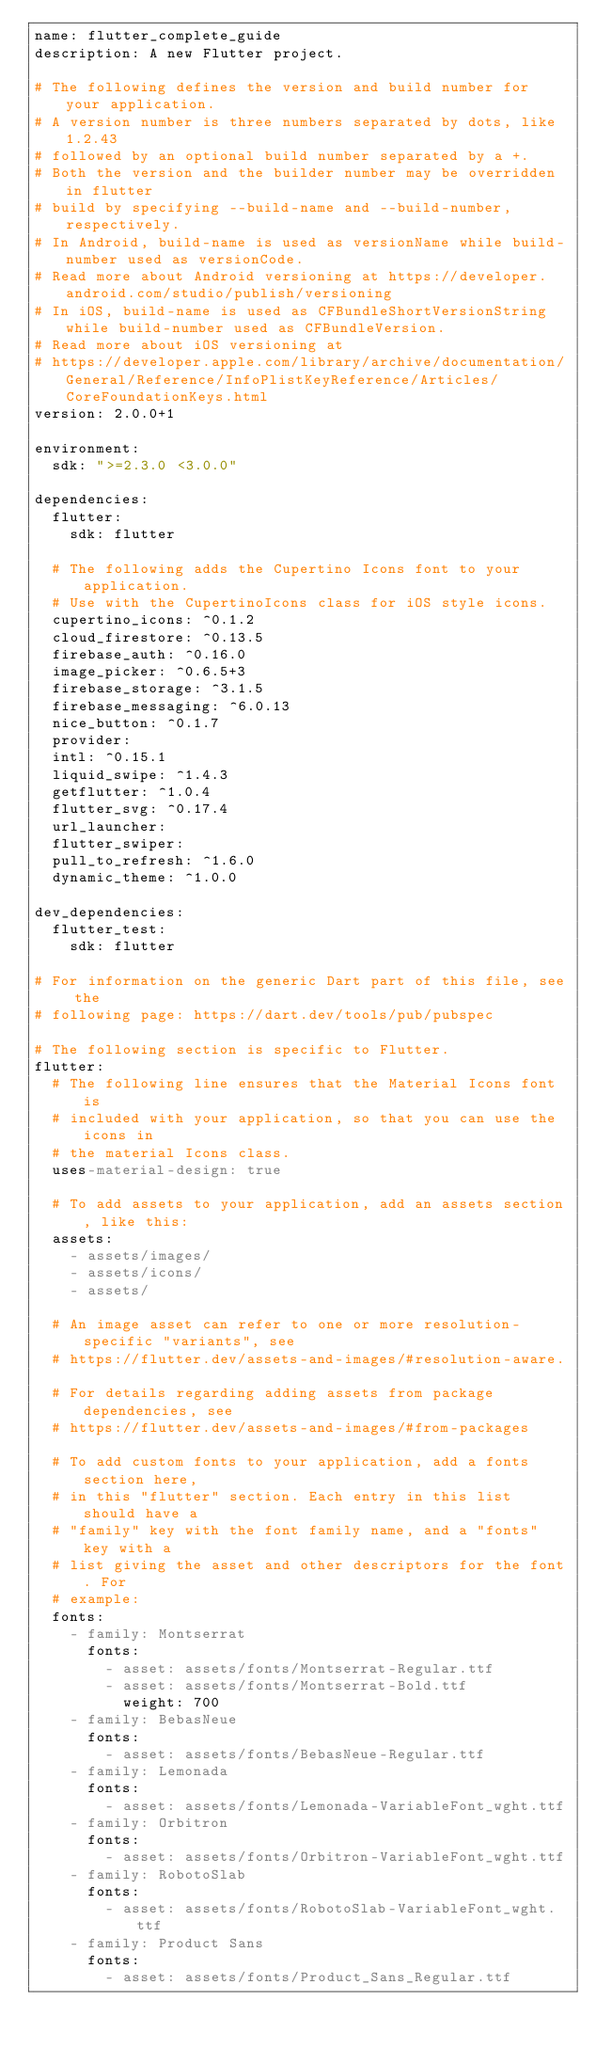Convert code to text. <code><loc_0><loc_0><loc_500><loc_500><_YAML_>name: flutter_complete_guide
description: A new Flutter project.

# The following defines the version and build number for your application.
# A version number is three numbers separated by dots, like 1.2.43
# followed by an optional build number separated by a +.
# Both the version and the builder number may be overridden in flutter
# build by specifying --build-name and --build-number, respectively.
# In Android, build-name is used as versionName while build-number used as versionCode.
# Read more about Android versioning at https://developer.android.com/studio/publish/versioning
# In iOS, build-name is used as CFBundleShortVersionString while build-number used as CFBundleVersion.
# Read more about iOS versioning at
# https://developer.apple.com/library/archive/documentation/General/Reference/InfoPlistKeyReference/Articles/CoreFoundationKeys.html
version: 2.0.0+1

environment:
  sdk: ">=2.3.0 <3.0.0"

dependencies:
  flutter:
    sdk: flutter

  # The following adds the Cupertino Icons font to your application.
  # Use with the CupertinoIcons class for iOS style icons.
  cupertino_icons: ^0.1.2
  cloud_firestore: ^0.13.5
  firebase_auth: ^0.16.0
  image_picker: ^0.6.5+3
  firebase_storage: ^3.1.5
  firebase_messaging: ^6.0.13
  nice_button: ^0.1.7
  provider:
  intl: ^0.15.1
  liquid_swipe: ^1.4.3
  getflutter: ^1.0.4
  flutter_svg: ^0.17.4
  url_launcher:
  flutter_swiper:
  pull_to_refresh: ^1.6.0
  dynamic_theme: ^1.0.0

dev_dependencies:
  flutter_test:
    sdk: flutter

# For information on the generic Dart part of this file, see the
# following page: https://dart.dev/tools/pub/pubspec

# The following section is specific to Flutter.
flutter:
  # The following line ensures that the Material Icons font is
  # included with your application, so that you can use the icons in
  # the material Icons class.
  uses-material-design: true

  # To add assets to your application, add an assets section, like this:
  assets:
    - assets/images/
    - assets/icons/
    - assets/

  # An image asset can refer to one or more resolution-specific "variants", see
  # https://flutter.dev/assets-and-images/#resolution-aware.

  # For details regarding adding assets from package dependencies, see
  # https://flutter.dev/assets-and-images/#from-packages

  # To add custom fonts to your application, add a fonts section here,
  # in this "flutter" section. Each entry in this list should have a
  # "family" key with the font family name, and a "fonts" key with a
  # list giving the asset and other descriptors for the font. For
  # example:
  fonts:
    - family: Montserrat
      fonts:
        - asset: assets/fonts/Montserrat-Regular.ttf
        - asset: assets/fonts/Montserrat-Bold.ttf
          weight: 700
    - family: BebasNeue
      fonts:
        - asset: assets/fonts/BebasNeue-Regular.ttf
    - family: Lemonada
      fonts:
        - asset: assets/fonts/Lemonada-VariableFont_wght.ttf
    - family: Orbitron
      fonts:
        - asset: assets/fonts/Orbitron-VariableFont_wght.ttf
    - family: RobotoSlab
      fonts:
        - asset: assets/fonts/RobotoSlab-VariableFont_wght.ttf
    - family: Product Sans
      fonts:
        - asset: assets/fonts/Product_Sans_Regular.ttf</code> 